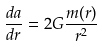<formula> <loc_0><loc_0><loc_500><loc_500>\frac { d a } { d r } = 2 G \frac { m ( r ) } { r ^ { 2 } }</formula> 